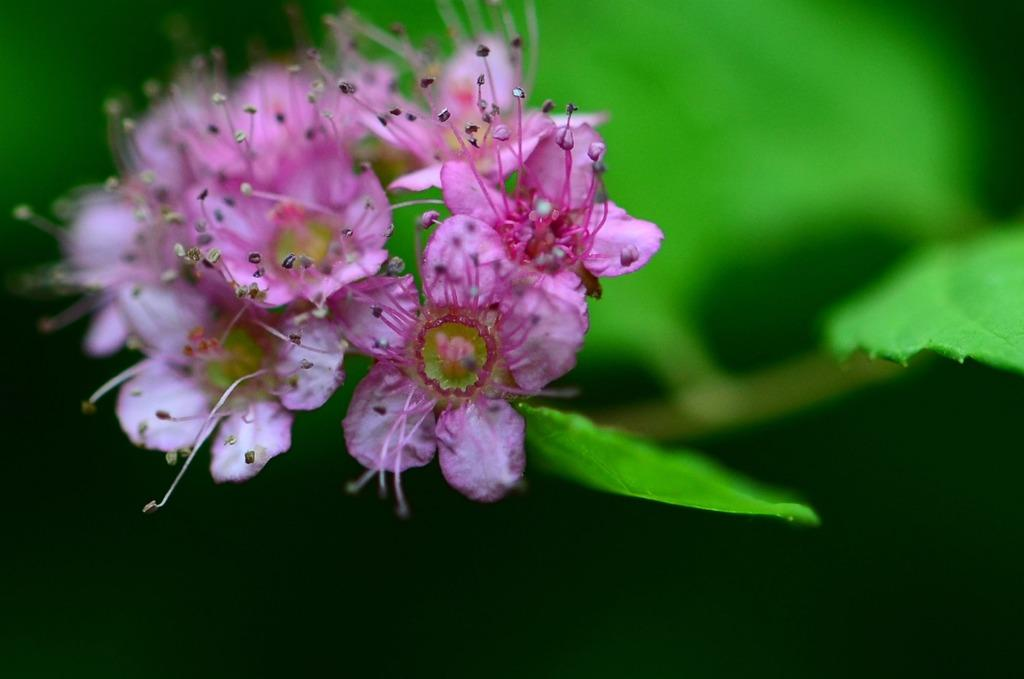What color are the flowers on the plant in the image? The flowers on the plant are pink. Where are the leaves located in the image? The leaves are on the right side of the image. What can be seen at the bottom of the image? There is darkness visible at the bottom of the image. How does the furniture in the image curve around the plant? There is no furniture present in the image, so it cannot curve around the plant. 